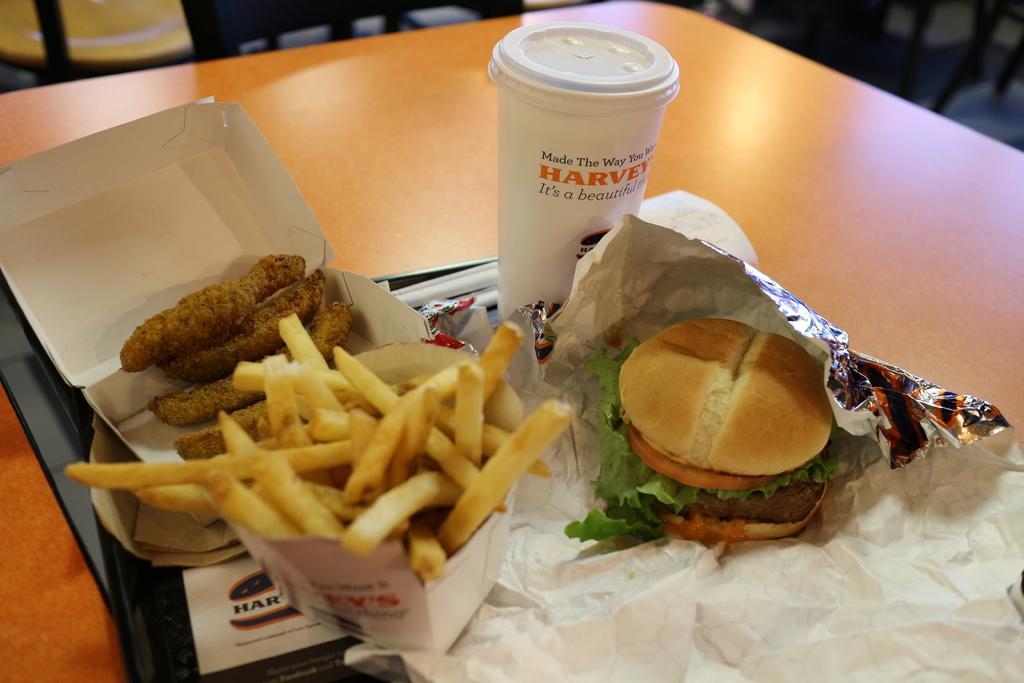Please provide a concise description of this image. In this image we can see a table. On the table there is a tray. On the tray there is a box with food item, box with french fries, aluminium foil with burger and a glass with a lid and text on it. 